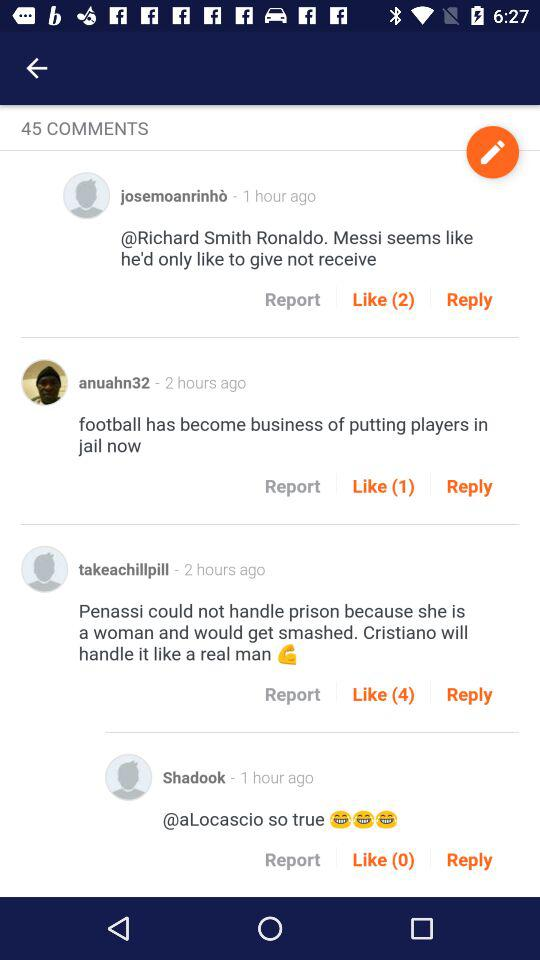How many likes are there for the comment by Shadook? There are 0 likes. 